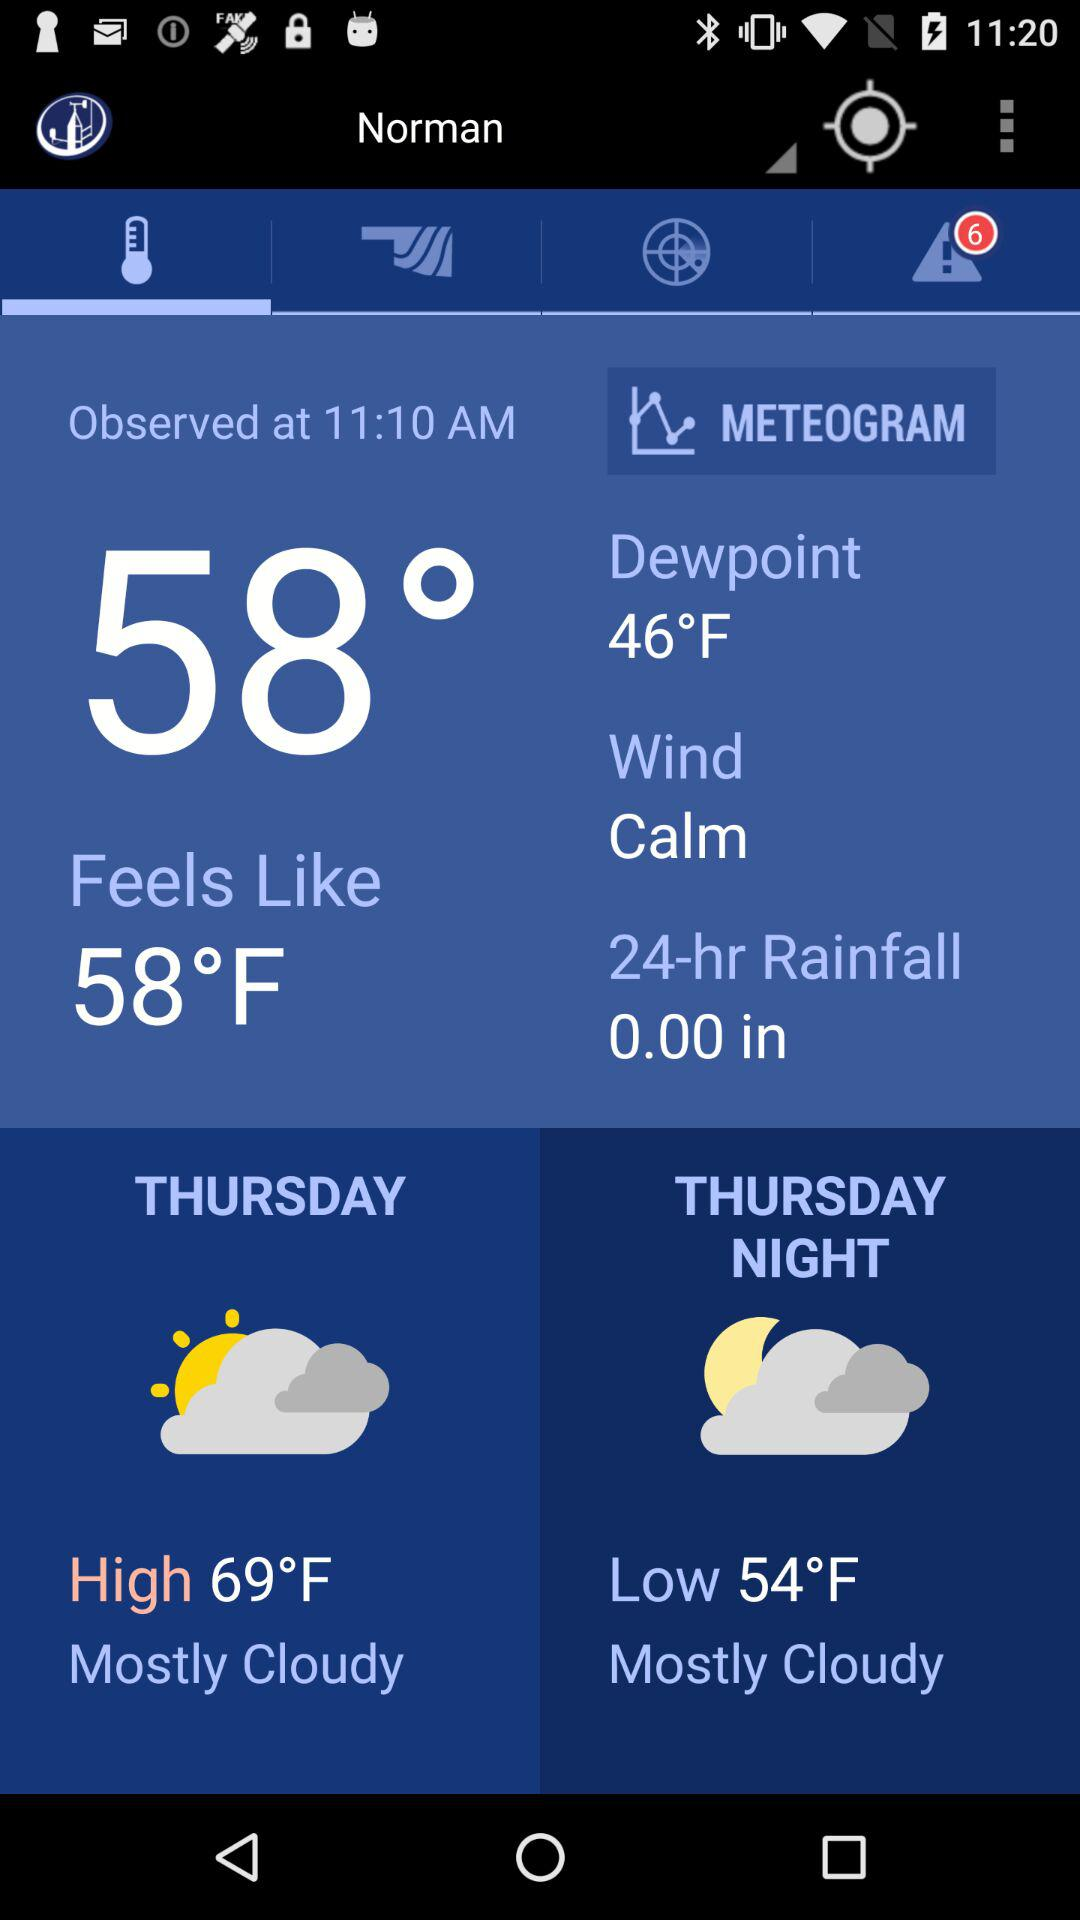What is the weather forecast for Thursday? The weather forecast is mostly cloudy. 